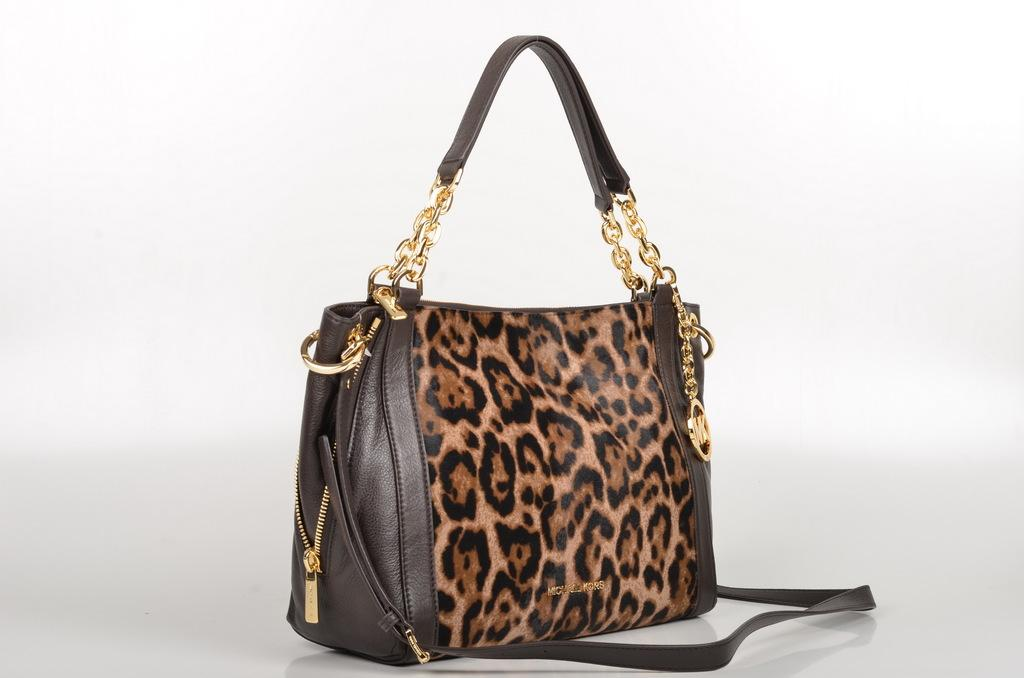What object can be seen in the image? There is a handbag in the image. Can you describe the appearance of the handbag? The handbag has a design. What additional feature is associated with the handbag? There are chains associated with the handbag. Where can the soap be found in the image? There is no soap present in the image. What type of store is shown in the image? The image does not depict a store; it features a handbag with a design and chains. 